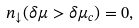Convert formula to latex. <formula><loc_0><loc_0><loc_500><loc_500>n _ { \downarrow } ( \delta \mu > \delta \mu _ { c } ) = 0 ,</formula> 